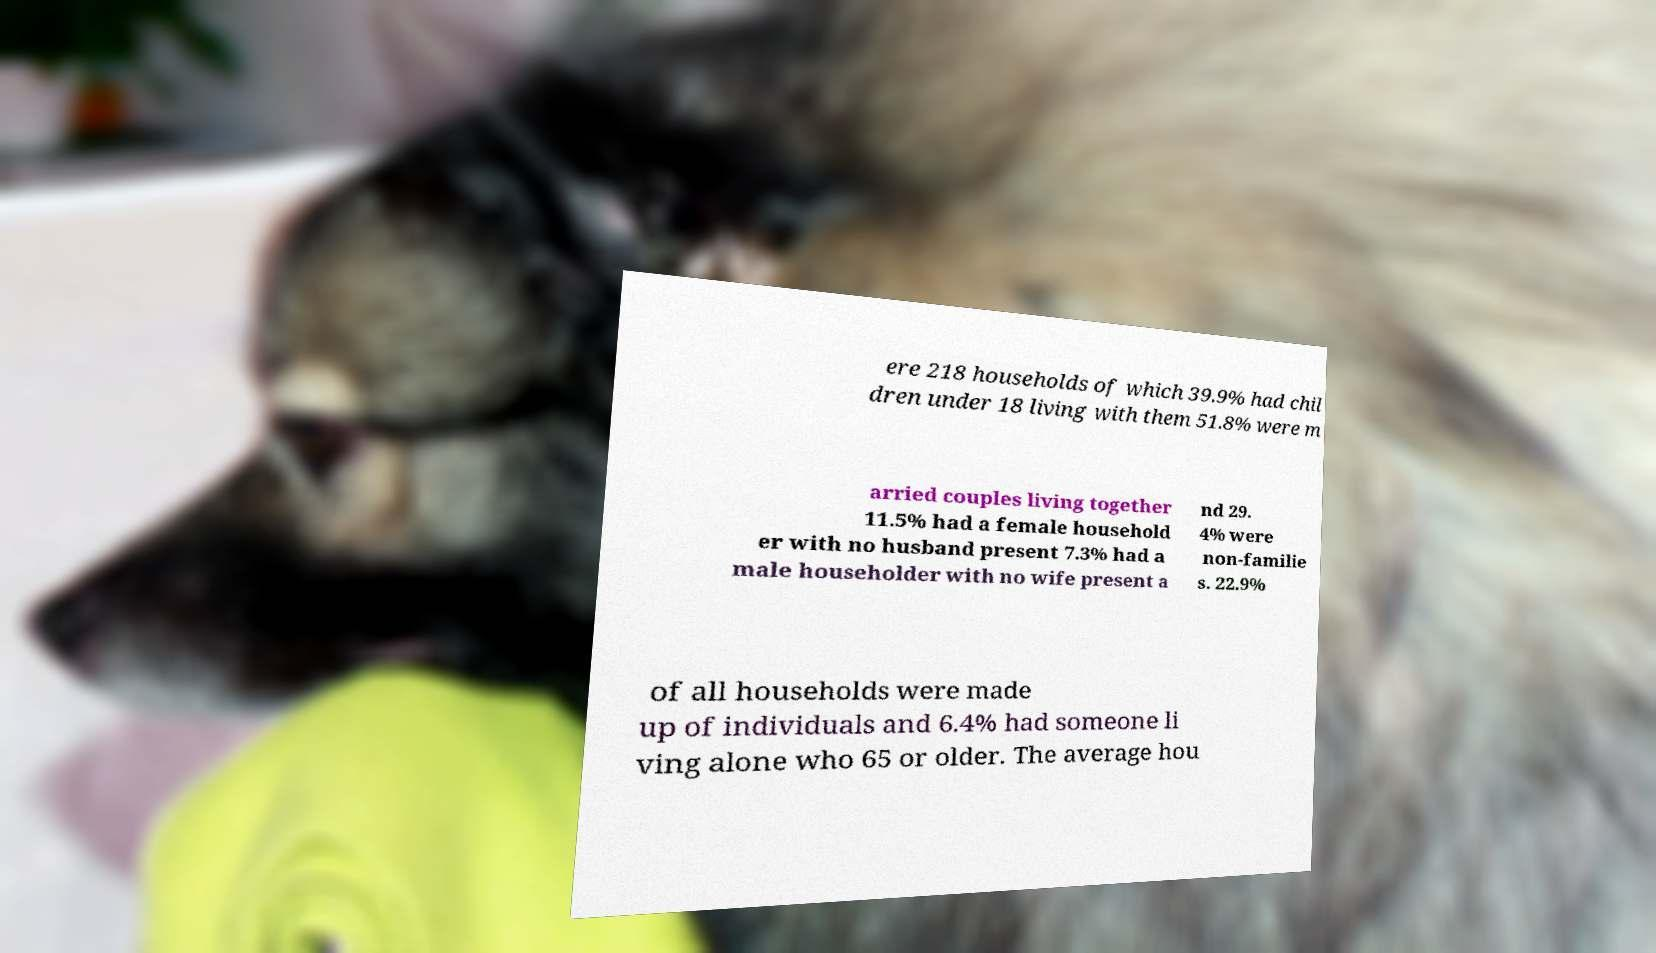Can you accurately transcribe the text from the provided image for me? ere 218 households of which 39.9% had chil dren under 18 living with them 51.8% were m arried couples living together 11.5% had a female household er with no husband present 7.3% had a male householder with no wife present a nd 29. 4% were non-familie s. 22.9% of all households were made up of individuals and 6.4% had someone li ving alone who 65 or older. The average hou 